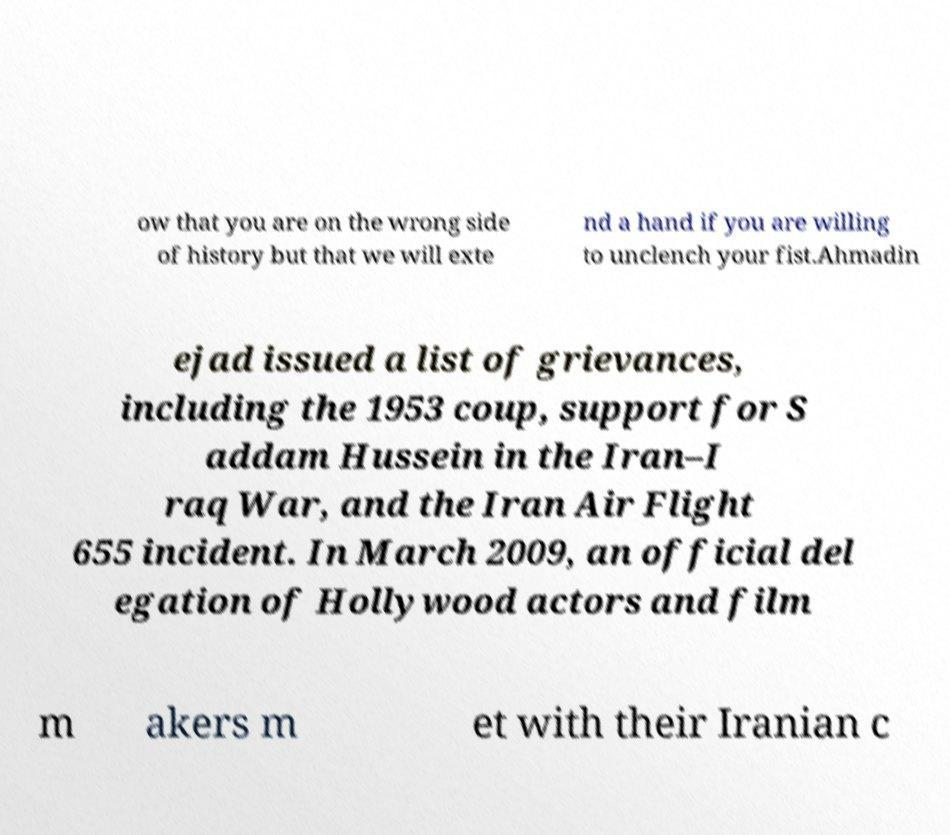Please read and relay the text visible in this image. What does it say? ow that you are on the wrong side of history but that we will exte nd a hand if you are willing to unclench your fist.Ahmadin ejad issued a list of grievances, including the 1953 coup, support for S addam Hussein in the Iran–I raq War, and the Iran Air Flight 655 incident. In March 2009, an official del egation of Hollywood actors and film m akers m et with their Iranian c 